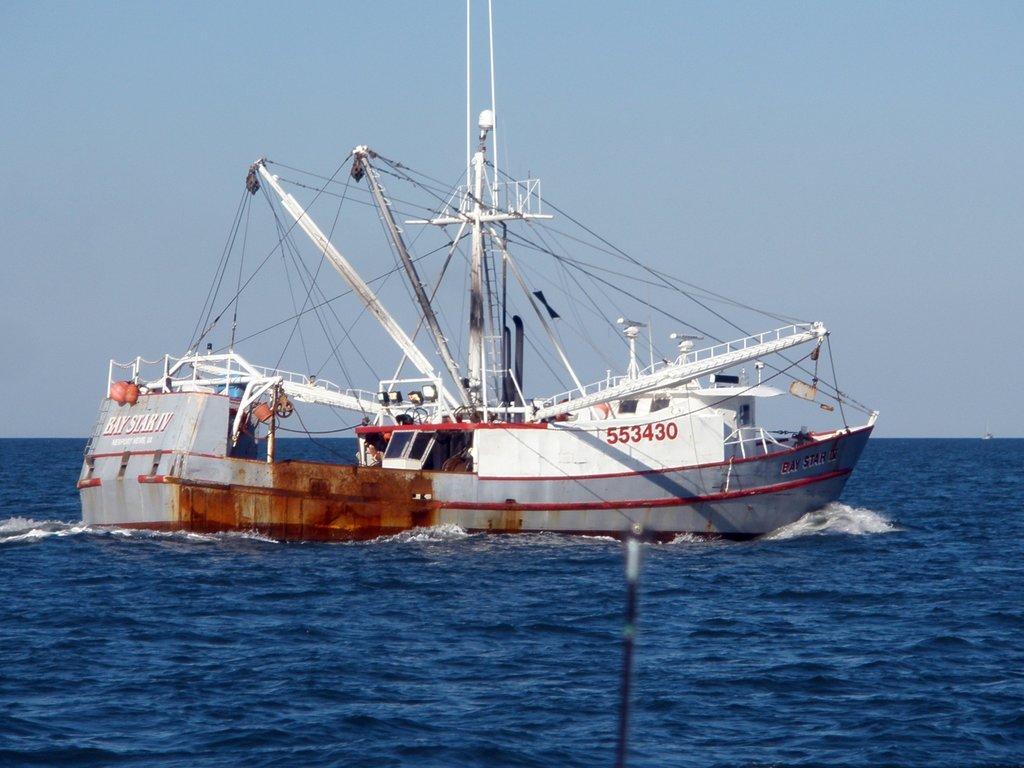Can you describe this image briefly? This image consists of ships along with poles. At the bottom, there is water. At the top, there is sky. It looks like it is clicked in an ocean. 